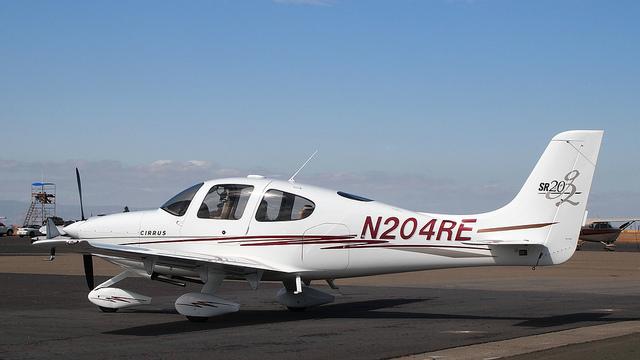What letters does this plane have on its side?
Write a very short answer. N204re. What kind of airplane is this?
Be succinct. Seaplane. How long is the airplane?
Concise answer only. Short. What main color is the plane?
Write a very short answer. White. How many planes are there?
Short answer required. 2. What number is shown on the tail and on the side?
Quick response, please. 20. What are all the different colors in the photo?
Keep it brief. Blue, grey, burgundy, white, black. What large letters are on the plane?
Quick response, please. N204re. Is the plane occupied?
Give a very brief answer. No. 